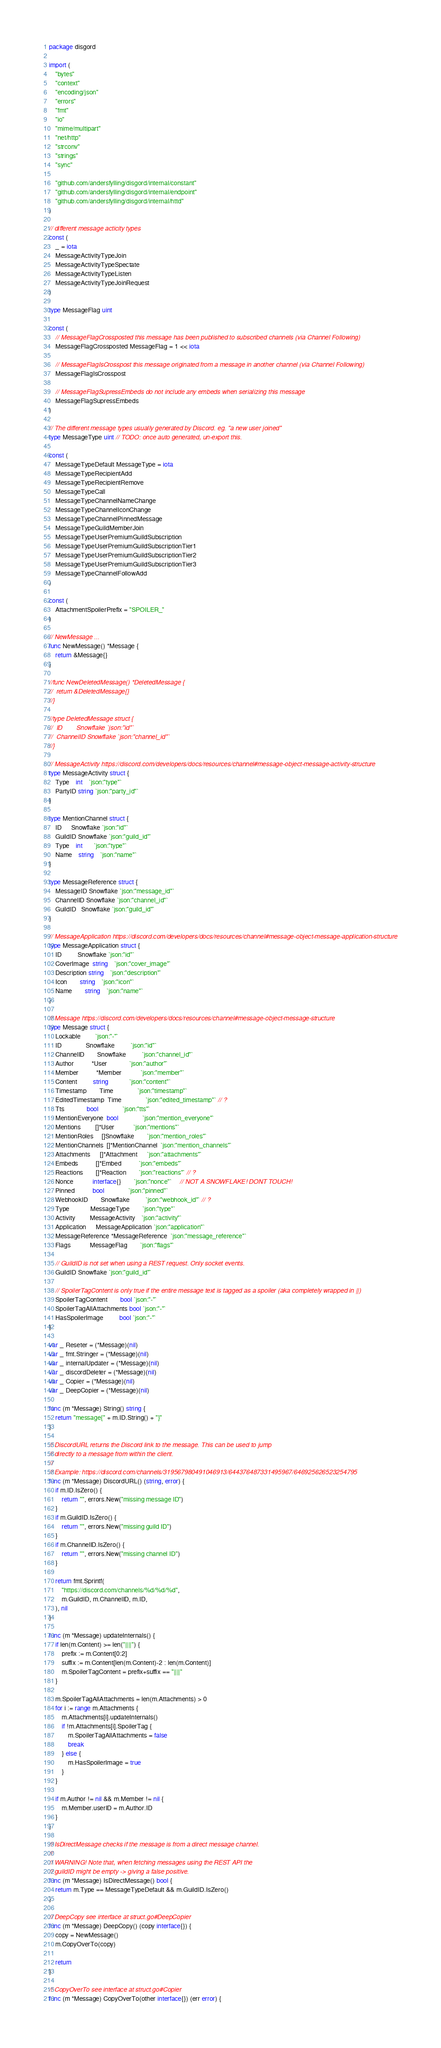Convert code to text. <code><loc_0><loc_0><loc_500><loc_500><_Go_>package disgord

import (
	"bytes"
	"context"
	"encoding/json"
	"errors"
	"fmt"
	"io"
	"mime/multipart"
	"net/http"
	"strconv"
	"strings"
	"sync"

	"github.com/andersfylling/disgord/internal/constant"
	"github.com/andersfylling/disgord/internal/endpoint"
	"github.com/andersfylling/disgord/internal/httd"
)

// different message acticity types
const (
	_ = iota
	MessageActivityTypeJoin
	MessageActivityTypeSpectate
	MessageActivityTypeListen
	MessageActivityTypeJoinRequest
)

type MessageFlag uint

const (
	// MessageFlagCrossposted this message has been published to subscribed channels (via Channel Following)
	MessageFlagCrossposted MessageFlag = 1 << iota

	// MessageFlagIsCrosspost this message originated from a message in another channel (via Channel Following)
	MessageFlagIsCrosspost

	// MessageFlagSupressEmbeds do not include any embeds when serializing this message
	MessageFlagSupressEmbeds
)

// The different message types usually generated by Discord. eg. "a new user joined"
type MessageType uint // TODO: once auto generated, un-export this.

const (
	MessageTypeDefault MessageType = iota
	MessageTypeRecipientAdd
	MessageTypeRecipientRemove
	MessageTypeCall
	MessageTypeChannelNameChange
	MessageTypeChannelIconChange
	MessageTypeChannelPinnedMessage
	MessageTypeGuildMemberJoin
	MessageTypeUserPremiumGuildSubscription
	MessageTypeUserPremiumGuildSubscriptionTier1
	MessageTypeUserPremiumGuildSubscriptionTier2
	MessageTypeUserPremiumGuildSubscriptionTier3
	MessageTypeChannelFollowAdd
)

const (
	AttachmentSpoilerPrefix = "SPOILER_"
)

// NewMessage ...
func NewMessage() *Message {
	return &Message{}
}

//func NewDeletedMessage() *DeletedMessage {
//	return &DeletedMessage{}
//}

//type DeletedMessage struct {
//	ID        Snowflake `json:"id"`
//	ChannelID Snowflake `json:"channel_id"`
//}

// MessageActivity https://discord.com/developers/docs/resources/channel#message-object-message-activity-structure
type MessageActivity struct {
	Type    int    `json:"type"`
	PartyID string `json:"party_id"`
}

type MentionChannel struct {
	ID      Snowflake `json:"id"`
	GuildID Snowflake `json:"guild_id"`
	Type    int       `json:"type"`
	Name    string    `json:"name"`
}

type MessageReference struct {
	MessageID Snowflake `json:"message_id"`
	ChannelID Snowflake `json:"channel_id"`
	GuildID   Snowflake `json:"guild_id"`
}

// MessageApplication https://discord.com/developers/docs/resources/channel#message-object-message-application-structure
type MessageApplication struct {
	ID          Snowflake `json:"id"`
	CoverImage  string    `json:"cover_image"`
	Description string    `json:"description"`
	Icon        string    `json:"icon"`
	Name        string    `json:"name"`
}

// Message https://discord.com/developers/docs/resources/channel#message-object-message-structure
type Message struct {
	Lockable         `json:"-"`
	ID               Snowflake          `json:"id"`
	ChannelID        Snowflake          `json:"channel_id"`
	Author           *User              `json:"author"`
	Member           *Member            `json:"member"`
	Content          string             `json:"content"`
	Timestamp        Time               `json:"timestamp"`
	EditedTimestamp  Time               `json:"edited_timestamp"` // ?
	Tts              bool               `json:"tts"`
	MentionEveryone  bool               `json:"mention_everyone"`
	Mentions         []*User            `json:"mentions"`
	MentionRoles     []Snowflake        `json:"mention_roles"`
	MentionChannels  []*MentionChannel  `json:"mention_channels"`
	Attachments      []*Attachment      `json:"attachments"`
	Embeds           []*Embed           `json:"embeds"`
	Reactions        []*Reaction        `json:"reactions"` // ?
	Nonce            interface{}        `json:"nonce"`     // NOT A SNOWFLAKE! DONT TOUCH!
	Pinned           bool               `json:"pinned"`
	WebhookID        Snowflake          `json:"webhook_id"` // ?
	Type             MessageType        `json:"type"`
	Activity         MessageActivity    `json:"activity"`
	Application      MessageApplication `json:"application"`
	MessageReference *MessageReference  `json:"message_reference"`
	Flags            MessageFlag        `json:"flags"`

	// GuildID is not set when using a REST request. Only socket events.
	GuildID Snowflake `json:"guild_id"`

	// SpoilerTagContent is only true if the entire message text is tagged as a spoiler (aka completely wrapped in ||)
	SpoilerTagContent        bool `json:"-"`
	SpoilerTagAllAttachments bool `json:"-"`
	HasSpoilerImage          bool `json:"-"`
}

var _ Reseter = (*Message)(nil)
var _ fmt.Stringer = (*Message)(nil)
var _ internalUpdater = (*Message)(nil)
var _ discordDeleter = (*Message)(nil)
var _ Copier = (*Message)(nil)
var _ DeepCopier = (*Message)(nil)

func (m *Message) String() string {
	return "message{" + m.ID.String() + "}"
}

// DiscordURL returns the Discord link to the message. This can be used to jump
// directly to a message from within the client.
//
// Example: https://discord.com/channels/319567980491046913/644376487331495967/646925626523254795
func (m *Message) DiscordURL() (string, error) {
	if m.ID.IsZero() {
		return "", errors.New("missing message ID")
	}
	if m.GuildID.IsZero() {
		return "", errors.New("missing guild ID")
	}
	if m.ChannelID.IsZero() {
		return "", errors.New("missing channel ID")
	}

	return fmt.Sprintf(
		"https://discord.com/channels/%d/%d/%d",
		m.GuildID, m.ChannelID, m.ID,
	), nil
}

func (m *Message) updateInternals() {
	if len(m.Content) >= len("||||") {
		prefix := m.Content[0:2]
		suffix := m.Content[len(m.Content)-2 : len(m.Content)]
		m.SpoilerTagContent = prefix+suffix == "||||"
	}

	m.SpoilerTagAllAttachments = len(m.Attachments) > 0
	for i := range m.Attachments {
		m.Attachments[i].updateInternals()
		if !m.Attachments[i].SpoilerTag {
			m.SpoilerTagAllAttachments = false
			break
		} else {
			m.HasSpoilerImage = true
		}
	}

	if m.Author != nil && m.Member != nil {
		m.Member.userID = m.Author.ID
	}
}

// IsDirectMessage checks if the message is from a direct message channel.
//
// WARNING! Note that, when fetching messages using the REST API the
// guildID might be empty -> giving a false positive.
func (m *Message) IsDirectMessage() bool {
	return m.Type == MessageTypeDefault && m.GuildID.IsZero()
}

// DeepCopy see interface at struct.go#DeepCopier
func (m *Message) DeepCopy() (copy interface{}) {
	copy = NewMessage()
	m.CopyOverTo(copy)

	return
}

// CopyOverTo see interface at struct.go#Copier
func (m *Message) CopyOverTo(other interface{}) (err error) {</code> 